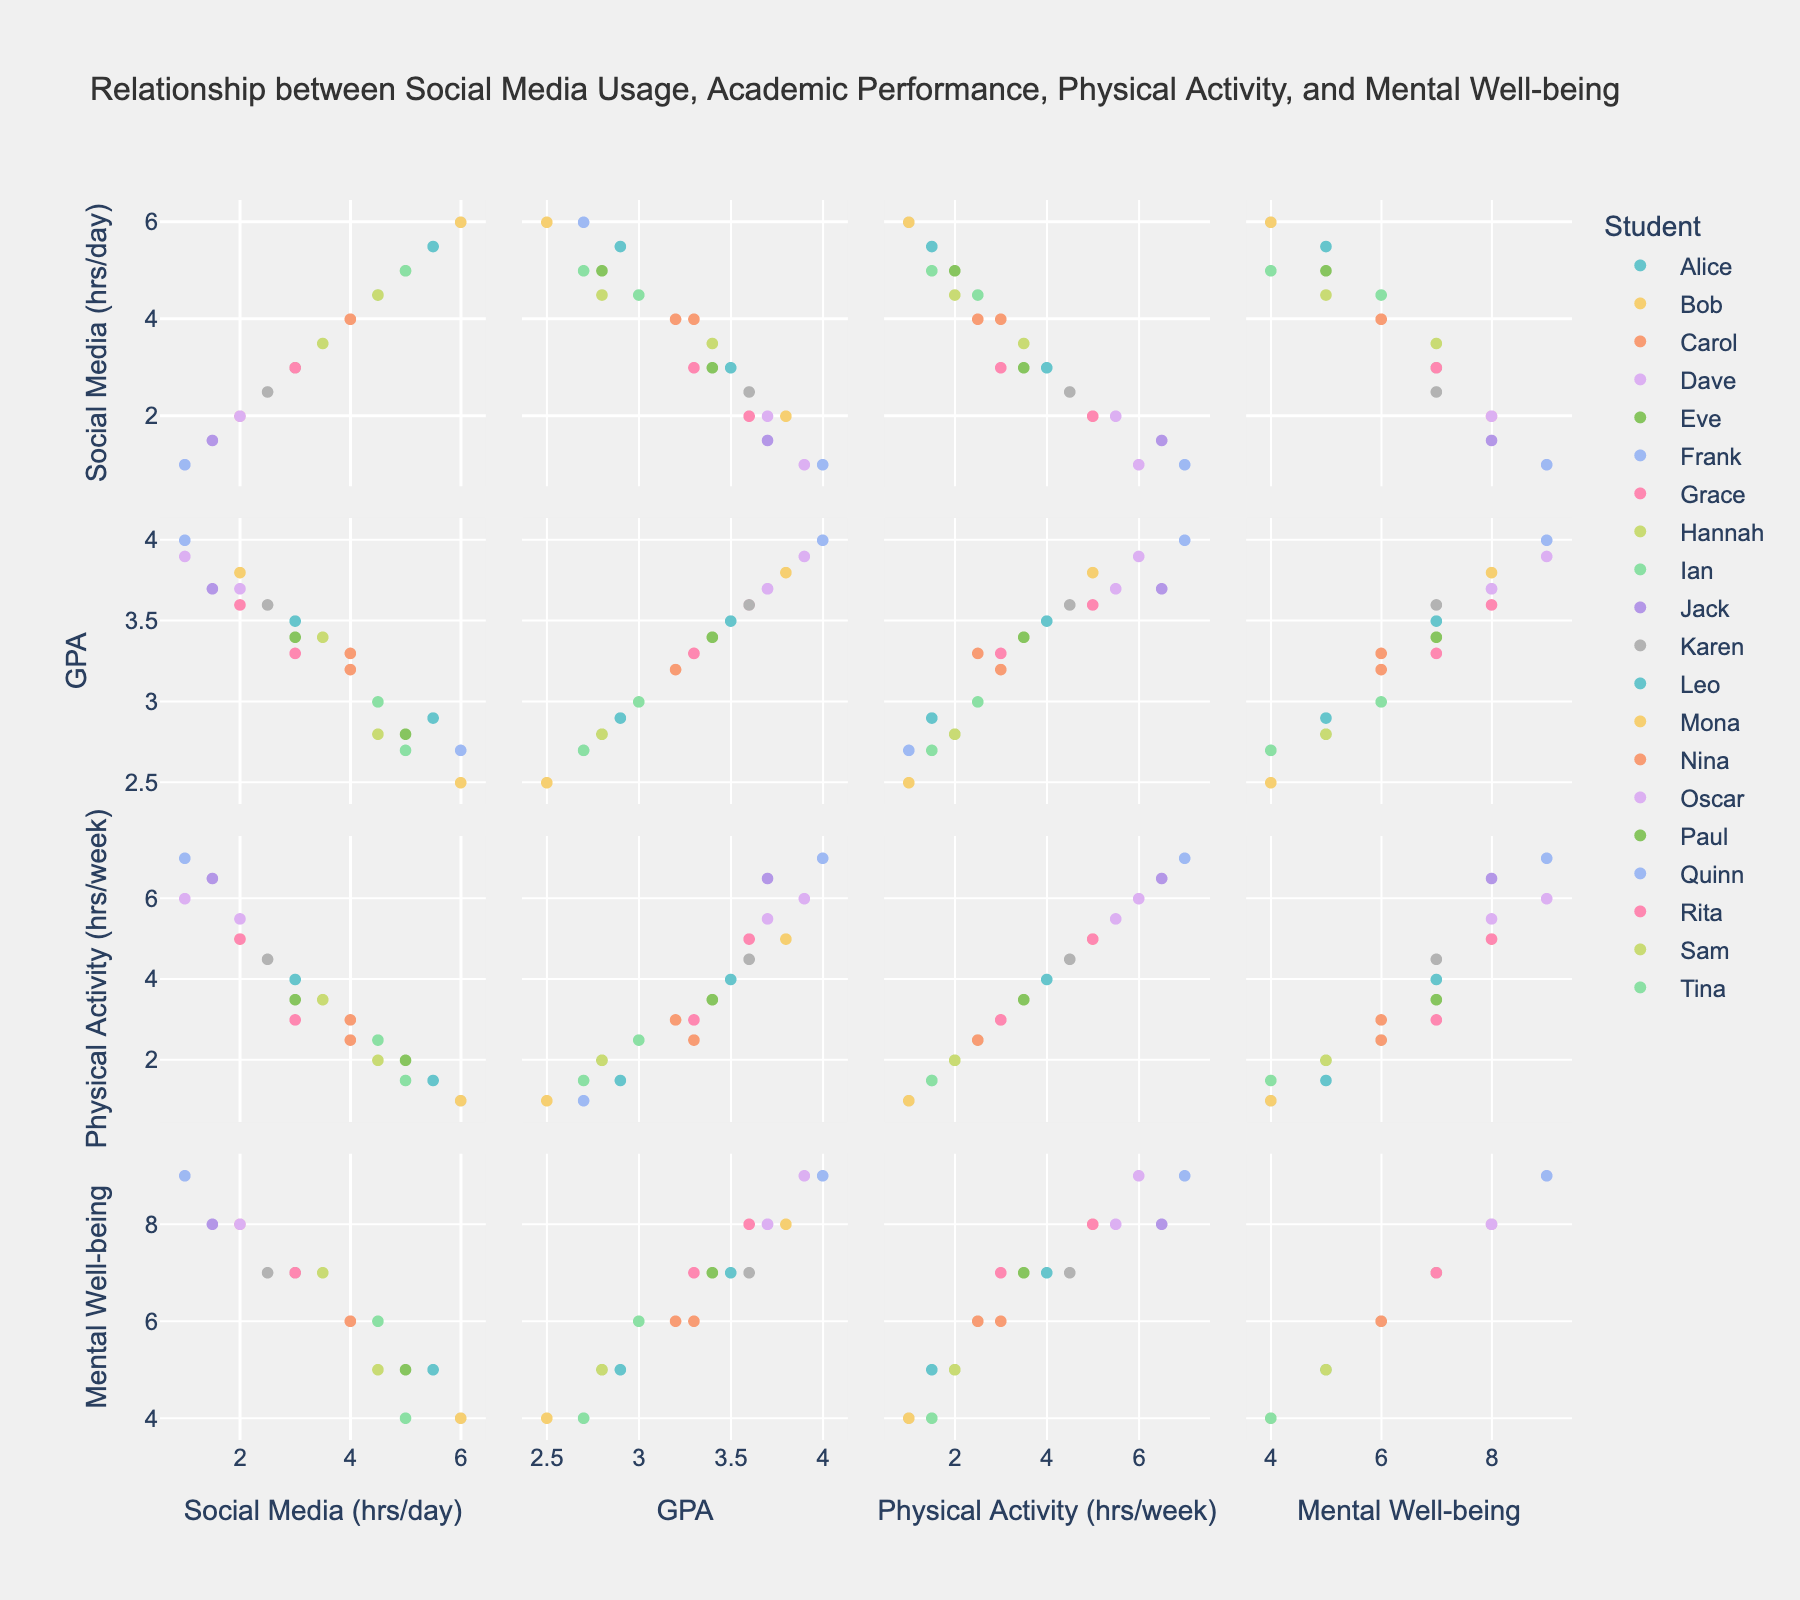What is the title of the plot? The title is usually displayed at the top of the plot and often summarizes the main content or purpose of the plot.
Answer: Relationship between Social Media Usage, Academic Performance, Physical Activity, and Mental Well-being How many dimensions are plotted in the matrix? The scatter plot matrix will display all possible pairwise combinations of these dimensions. By counting the number of unique dimensions/axes, we can determine the number of dimensions.
Answer: Four Which student spends the most hours on social media per day? Look for the highest value on the 'Social Media Hours per Day' axis and identify the corresponding data point or color.
Answer: Mona and Frank Is there a visible trend between 'Social Media Hours per Day' and 'Academic Performance (GPA)'? Observe the scatter plot involving these two dimensions to see if there's a general upward or downward trend.
Answer: Downward trend Who has the highest GPA? Locate the highest value on the 'Academic Performance (GPA)' axis and check which student it corresponds to.
Answer: Quinn What is the range of the 'Mental Well-being Score'? Examine the minimum and maximum values on the 'Mental Well-being Score' axis to determine the range.
Answer: 4 to 9 What is the average 'Physical Activity Hours per Week' for students who spend more than 4 hours per day on social media? Identify the students who spend more than 4 hours on social media, sum their 'Physical Activity Hours per Week' values, and divide by the number of these students.
Answer: (2 + 1 + 1.5 + 1 + 2)/5 = 1.5 Describe the relationship between 'Physical Activity Hours per Week' and 'Mental Well-being Score'. Check the plot containing these two axes to see if there is any visible correlation.
Answer: Positive correlation Which student has the highest 'Mental Well-being Score' and how many hours per week do they spend on physical activity? Identify the highest data point for the 'Mental Well-being Score' and note the corresponding 'Physical Activity Hours per Week'.
Answer: Dave and Quinn, 6 and 7 hours respectively What can you infer about students who have a GPA of 3.6 or above in terms of 'Social Media Hours per Day'? Determine the 'Social Media Hours per Day' for students with a GPA of 3.6 or higher, and compare these values to see if there is any pattern.
Answer: Generally low social media usage Is there a cluster of students with high physical activity and mental well-being? Look for a group of data points with both high 'Physical Activity Hours per Week' and 'Mental Well-being Score'.
Answer: Yes, students with high values (5-9) tend to cluster together 